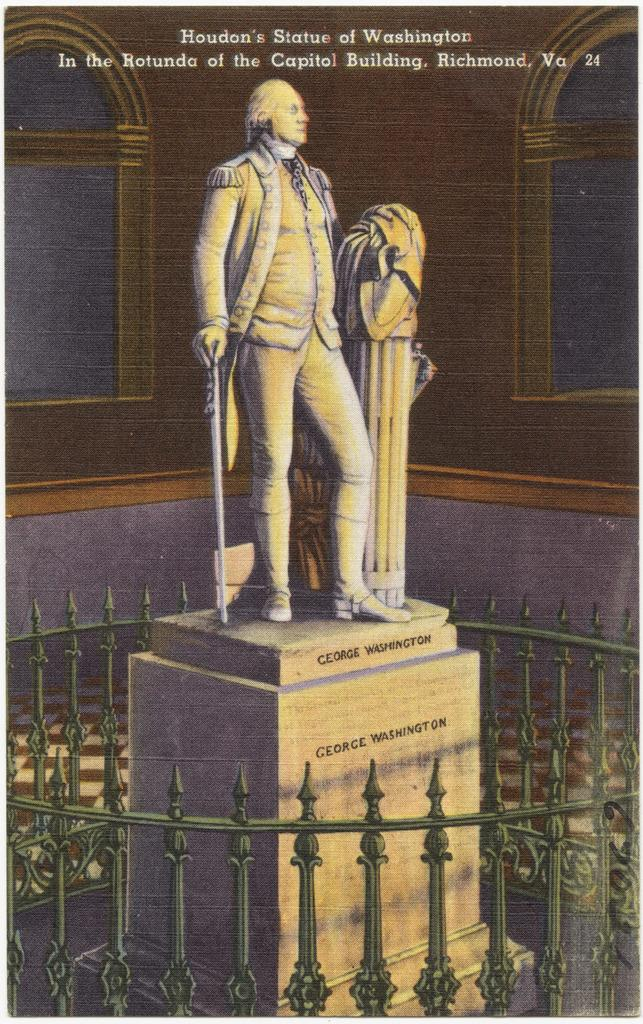What is the main subject of the image? There is a statue of a person in the image. What is the person in the image doing? A person is holding an object in the image. What type of barrier can be seen in the image? There is a fence in the image. What is written or displayed at the top of the image? There is some text at the top of the image. What color of paint is being used to create the line on the statue in the image? There is no line or paint present on the statue in the image; it is a solid sculpture. 